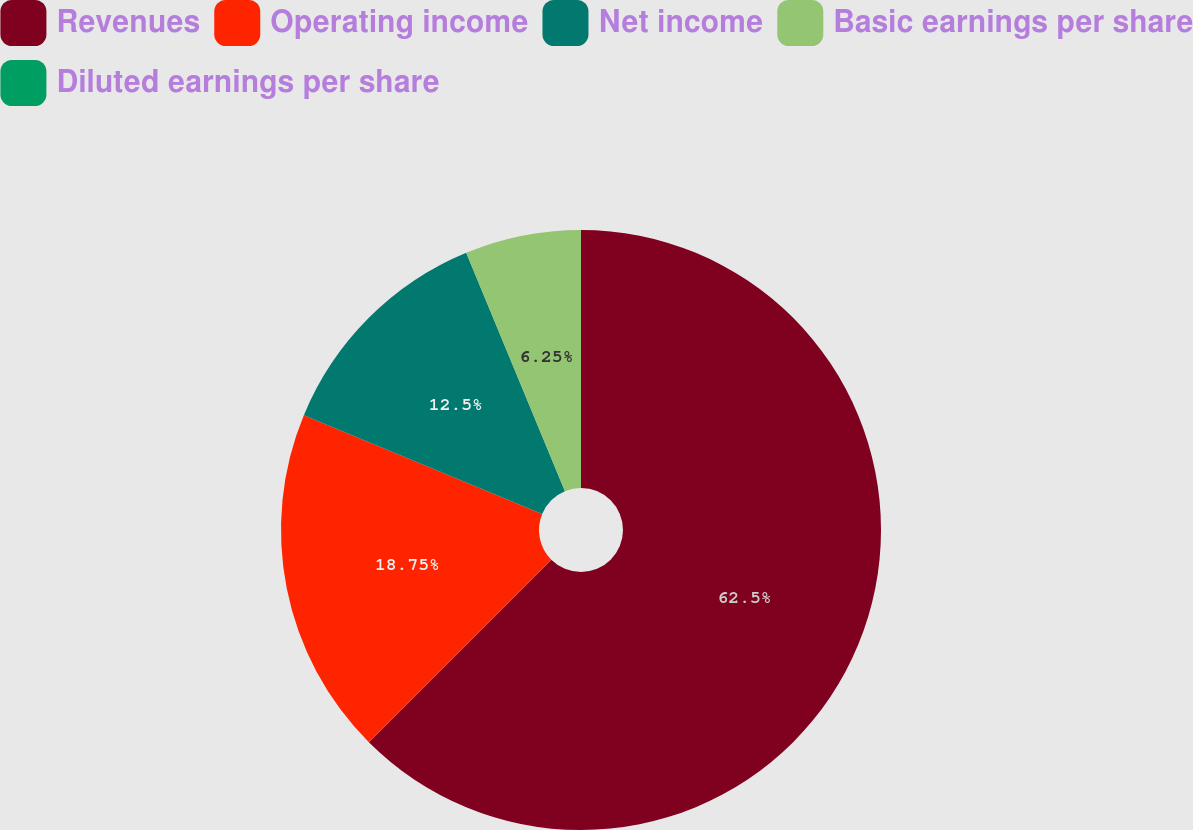Convert chart. <chart><loc_0><loc_0><loc_500><loc_500><pie_chart><fcel>Revenues<fcel>Operating income<fcel>Net income<fcel>Basic earnings per share<fcel>Diluted earnings per share<nl><fcel>62.5%<fcel>18.75%<fcel>12.5%<fcel>6.25%<fcel>0.0%<nl></chart> 